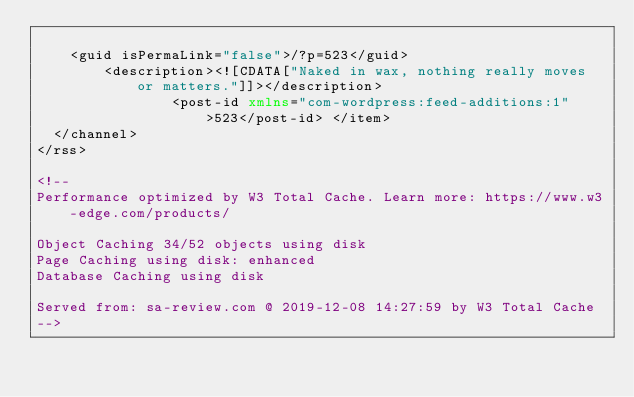<code> <loc_0><loc_0><loc_500><loc_500><_XML_>
		<guid isPermaLink="false">/?p=523</guid>
				<description><![CDATA["Naked in wax, nothing really moves or matters."]]></description>
								<post-id xmlns="com-wordpress:feed-additions:1">523</post-id>	</item>
	</channel>
</rss>

<!--
Performance optimized by W3 Total Cache. Learn more: https://www.w3-edge.com/products/

Object Caching 34/52 objects using disk
Page Caching using disk: enhanced 
Database Caching using disk

Served from: sa-review.com @ 2019-12-08 14:27:59 by W3 Total Cache
--></code> 